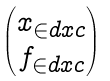Convert formula to latex. <formula><loc_0><loc_0><loc_500><loc_500>\begin{pmatrix} x _ { \in d x c } \\ f _ { \in d x c } \end{pmatrix}</formula> 